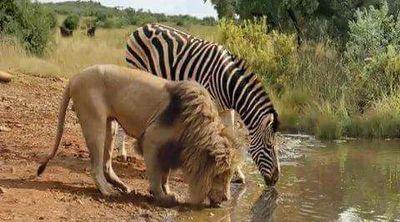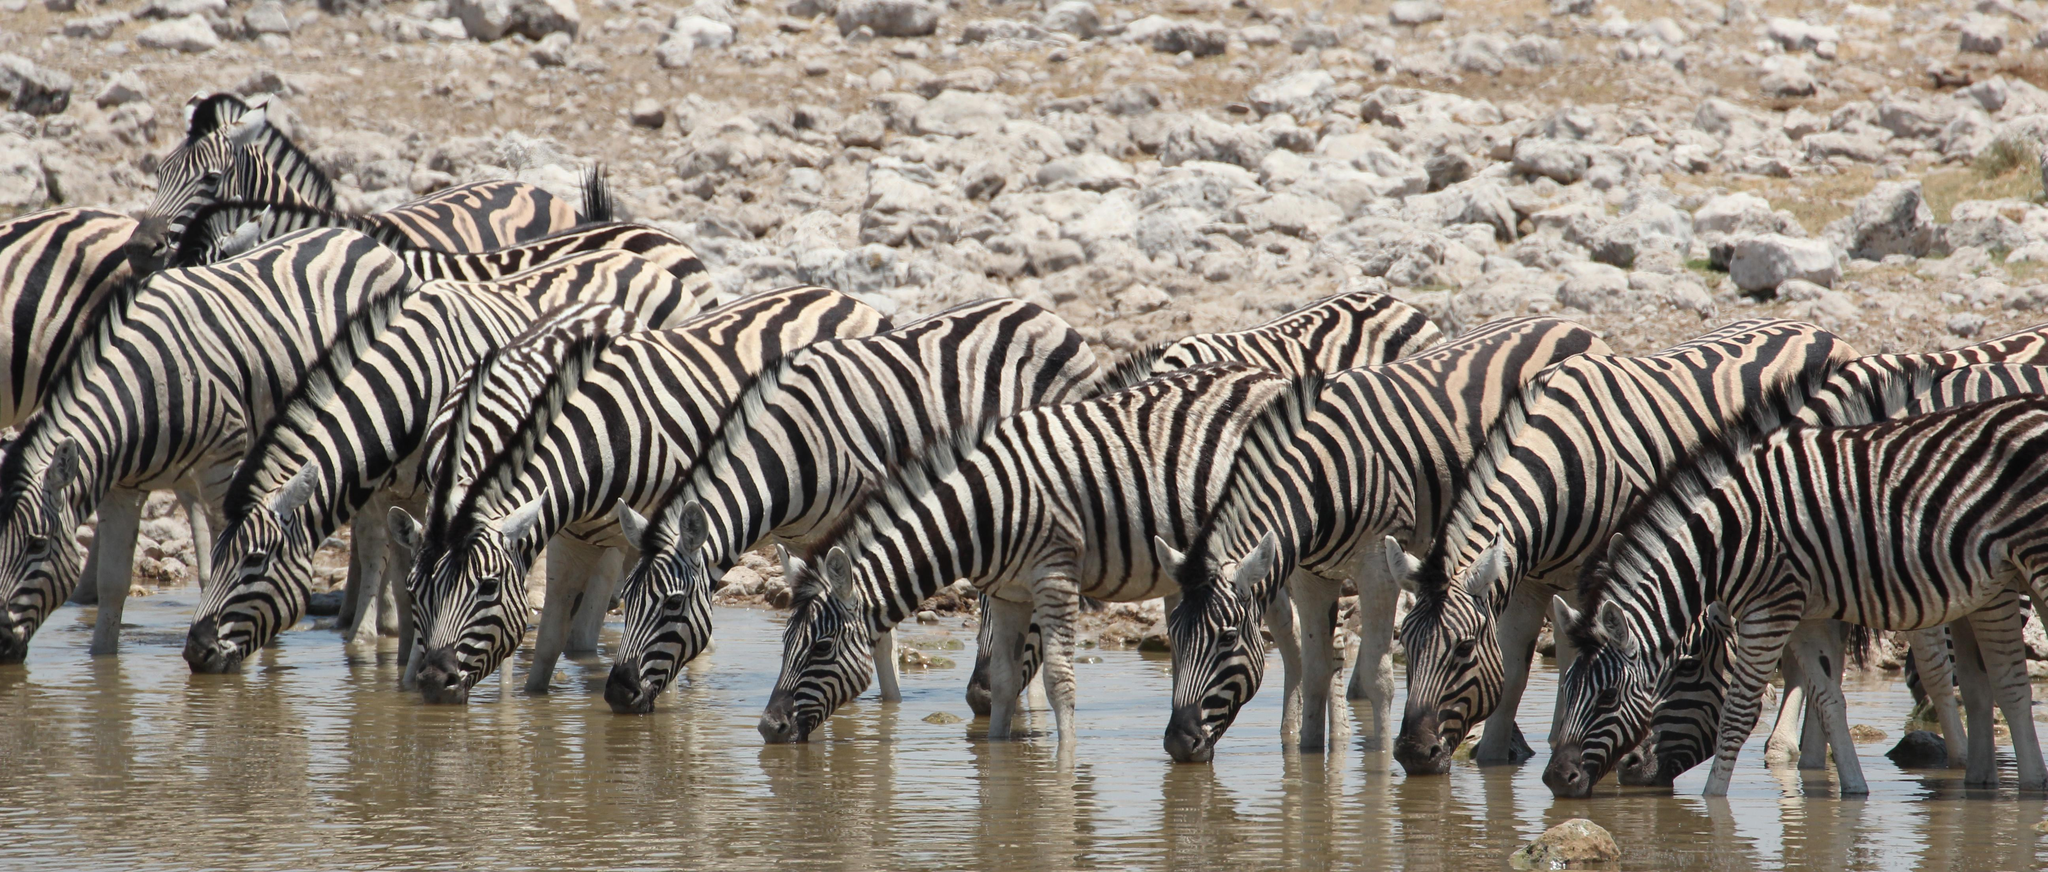The first image is the image on the left, the second image is the image on the right. Given the left and right images, does the statement "One image shows at least 8 zebras lined up close together to drink, and the other image shows a zebra and a different type of animal near a pool of water." hold true? Answer yes or no. Yes. The first image is the image on the left, the second image is the image on the right. Considering the images on both sides, is "The left image contains no more than three zebras." valid? Answer yes or no. Yes. 